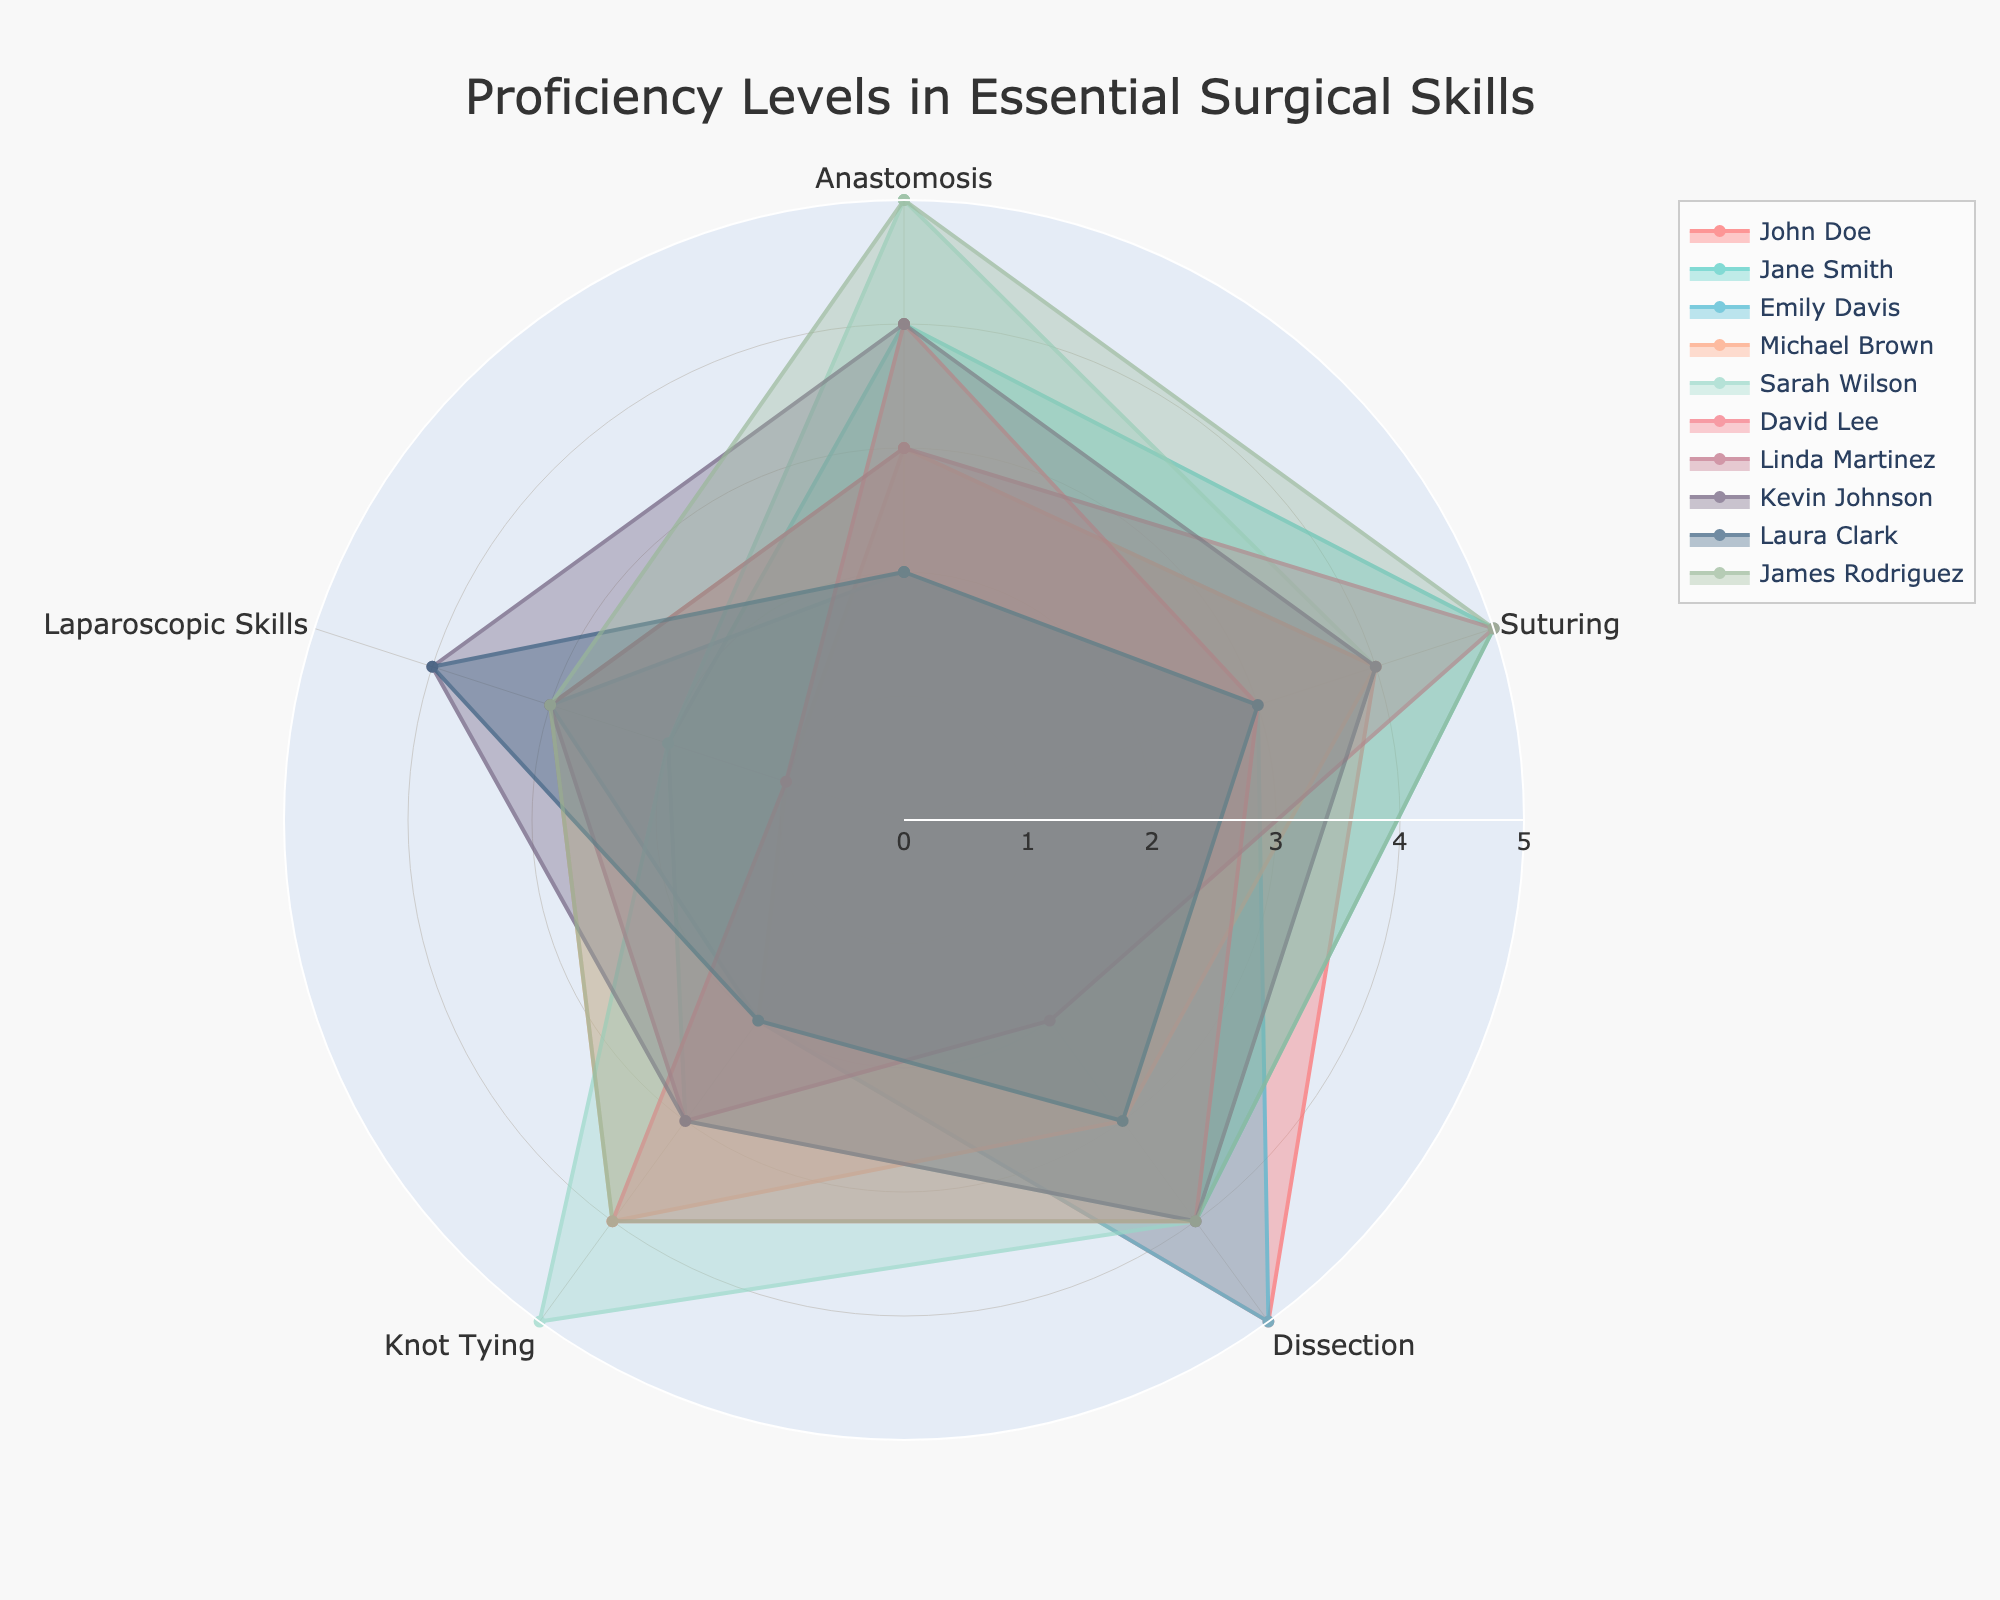What is the title of the radar chart? The title of the radar chart is usually prominently displayed at the top of the figure. Here, it reads 'Proficiency Levels in Essential Surgical Skills'.
Answer: Proficiency Levels in Essential Surgical Skills Which student has the highest proficiency in Knot Tying? By looking at the radar chart, you can find the proficiency levels in Knot Tying on the respective axis. Sarah Wilson has a proficiency level of 5 in Knot Tying, which is the highest.
Answer: Sarah Wilson What is the average proficiency level for Suturing among all students? To find the average proficiency level, sum up the Suturing values for all students and divide by the number of students. The values are 4, 5, 3, 4, 4, 3, 5, 4, 3, and 5. Sum these values to get 40. There are 10 students, so the average is 40/10.
Answer: 4 Which two students have the same proficiency levels across all skills? Looking closely at each individual radar plot, we see that Kevin Johnson and Michael Brown have the same proficiency levels for all skills: 4 for Anastomosis, 4 for Suturing, 4 for Dissection, 3 for Knot Tying, and 4 for Laparoscopic Skills.
Answer: Kevin Johnson and Michael Brown How many students have a proficiency level of 5 in Dissection? By examining the Dissection axis on the radar chart, we can count the number of students who reach a proficiency level of 5. There are two students: John Doe and Emily Davis.
Answer: 2 Who has the lowest overall proficiency in Laparoscopic Skills? The overall proficiency can be identified by looking at the outerbounds of the Laparoscopic Skills axis. John Doe and David Lee both have the lowest proficiency level of 1 in Laparoscopic Skills.
Answer: John Doe and David Lee Which student shows balanced proficiency levels across all skills? Balancing proficiency implies that the levels are consistently similar across different skill areas. Kevin Johnson shows balanced levels of 4 across Anastomosis, Suturing, Dissection, Knot Tying, and Laparoscopic Skills.
Answer: Kevin Johnson Which skill area has the greatest variance in proficiency levels among the students? To determine variance, observe the range of values along each axis. Knot Tying shows the greatest variance, with proficiency levels ranging from 2 to 5.
Answer: Knot Tying What is the median proficiency level for Dissection? To find the median, list the proficiency levels for Dissection, which are 5, 4, 5, 3, 4, 4, 2, 4, 3, 4. Arrange them in ascending order (2, 3, 3, 4, 4, 4, 4, 4, 5, 5). The median is the middle value in this ordered list, which here is 4.
Answer: 4 